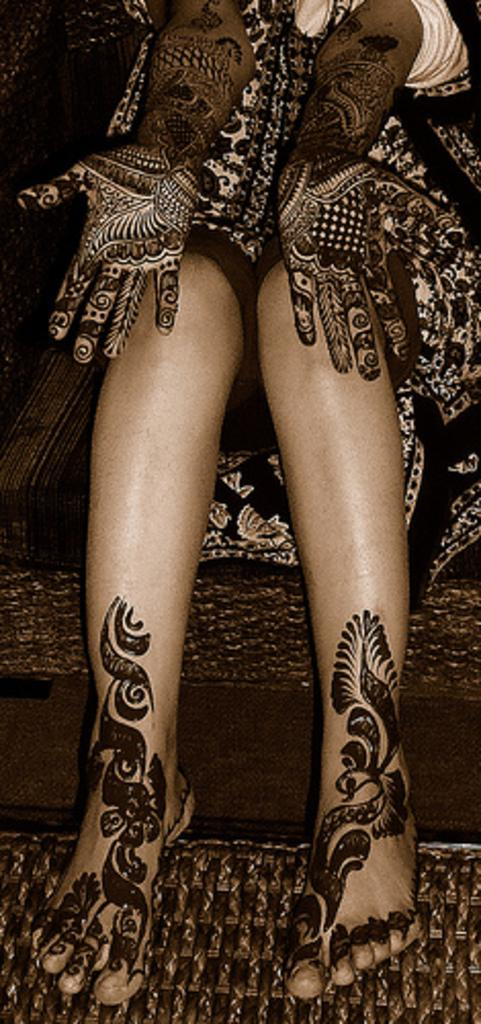Who or what is the main subject in the image? There is a person in the image. What can be observed on the person's hands and legs? The person has mehndi art on their hands and legs. What is located at the bottom of the image? There is a mat at the bottom of the image. What type of collar can be seen around the person's neck in the image? There is no collar visible around the person's neck in the image. What color is the paint on the person's mouth in the image? There is no paint on the person's mouth in the image. 